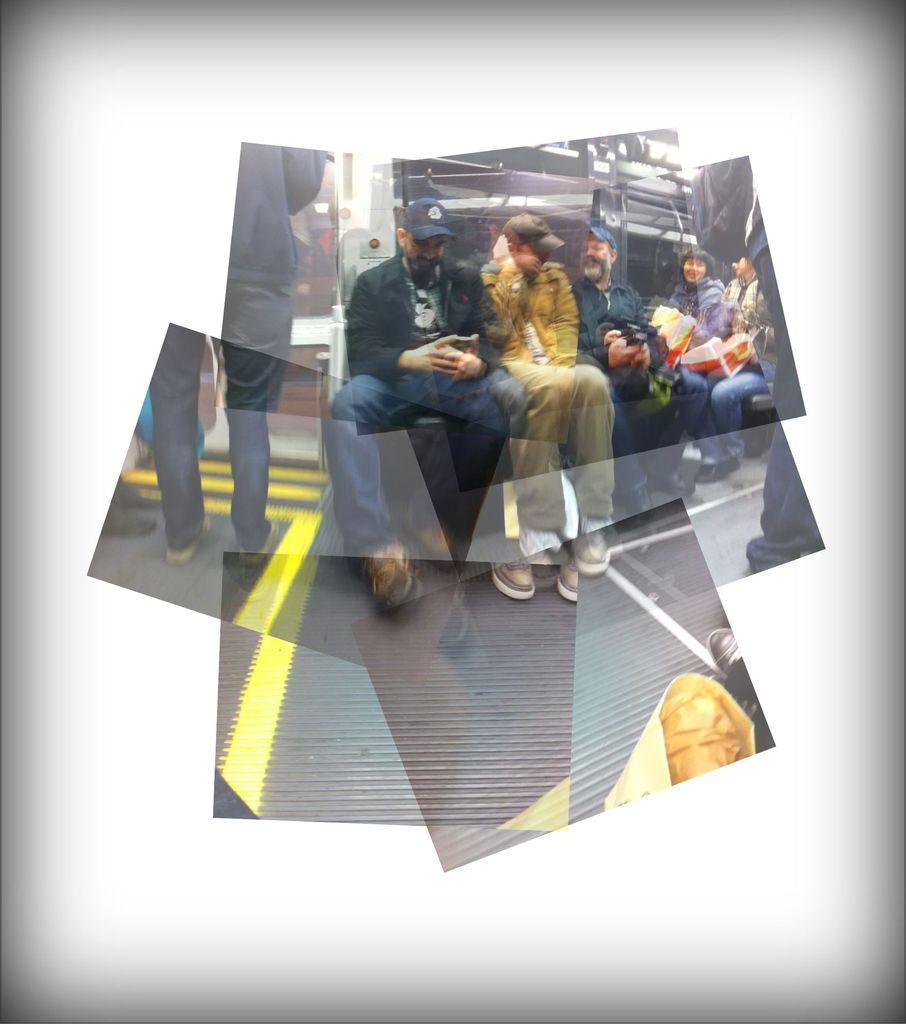What can be observed about the image's appearance? The image is edited. What is the main focus of the image? There are people in the center of the image. What type of wound can be seen on the person in the image? There is no wound visible on any person in the image. Is there a boat present in the image? No, there is no boat present in the image. 